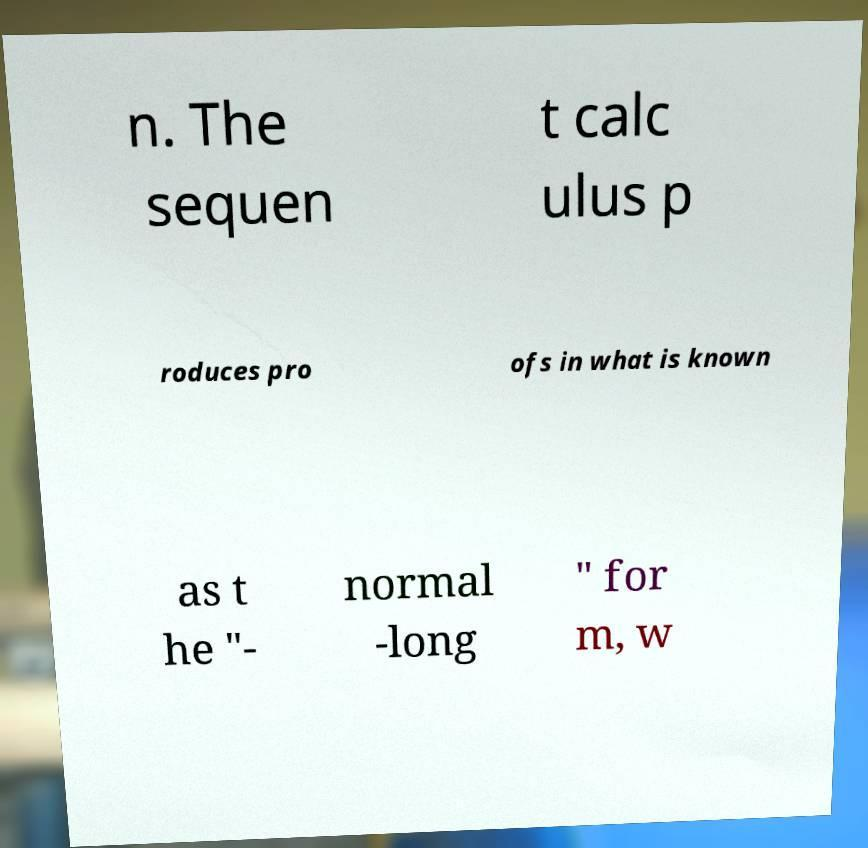Can you read and provide the text displayed in the image?This photo seems to have some interesting text. Can you extract and type it out for me? n. The sequen t calc ulus p roduces pro ofs in what is known as t he "- normal -long " for m, w 